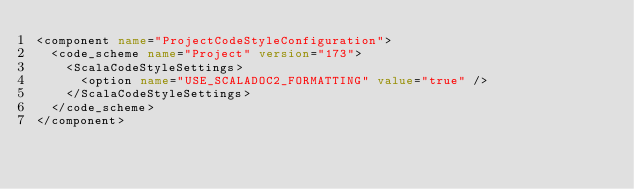<code> <loc_0><loc_0><loc_500><loc_500><_XML_><component name="ProjectCodeStyleConfiguration">
  <code_scheme name="Project" version="173">
    <ScalaCodeStyleSettings>
      <option name="USE_SCALADOC2_FORMATTING" value="true" />
    </ScalaCodeStyleSettings>
  </code_scheme>
</component></code> 